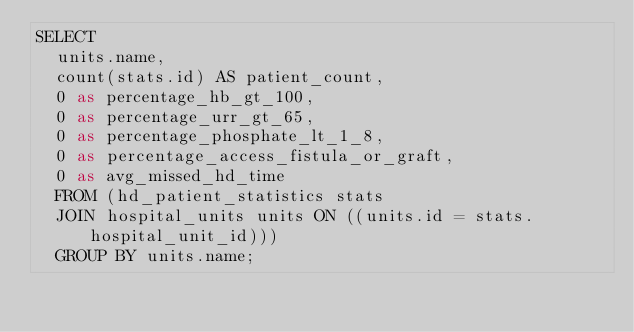Convert code to text. <code><loc_0><loc_0><loc_500><loc_500><_SQL_>SELECT
  units.name,
  count(stats.id) AS patient_count,
  0 as percentage_hb_gt_100,
  0 as percentage_urr_gt_65,
  0 as percentage_phosphate_lt_1_8,
  0 as percentage_access_fistula_or_graft,
  0 as avg_missed_hd_time
  FROM (hd_patient_statistics stats
  JOIN hospital_units units ON ((units.id = stats.hospital_unit_id)))
  GROUP BY units.name;
</code> 